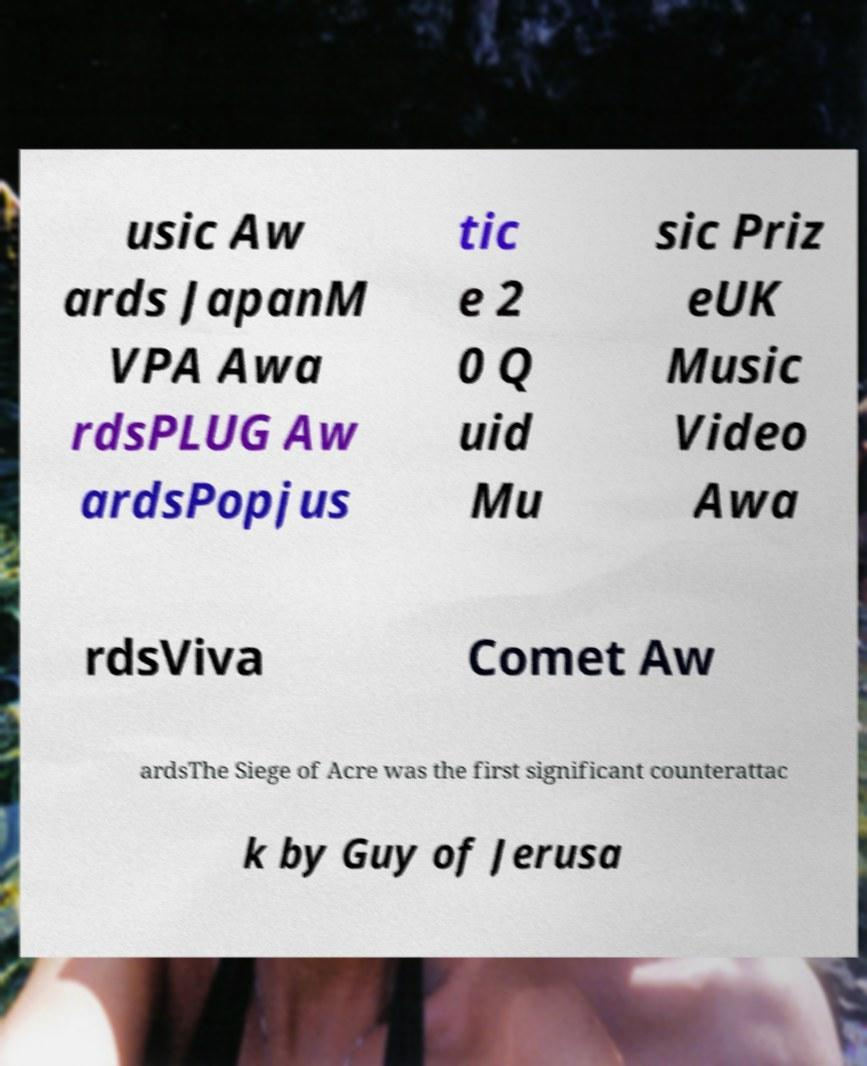Can you read and provide the text displayed in the image?This photo seems to have some interesting text. Can you extract and type it out for me? usic Aw ards JapanM VPA Awa rdsPLUG Aw ardsPopjus tic e 2 0 Q uid Mu sic Priz eUK Music Video Awa rdsViva Comet Aw ardsThe Siege of Acre was the first significant counterattac k by Guy of Jerusa 